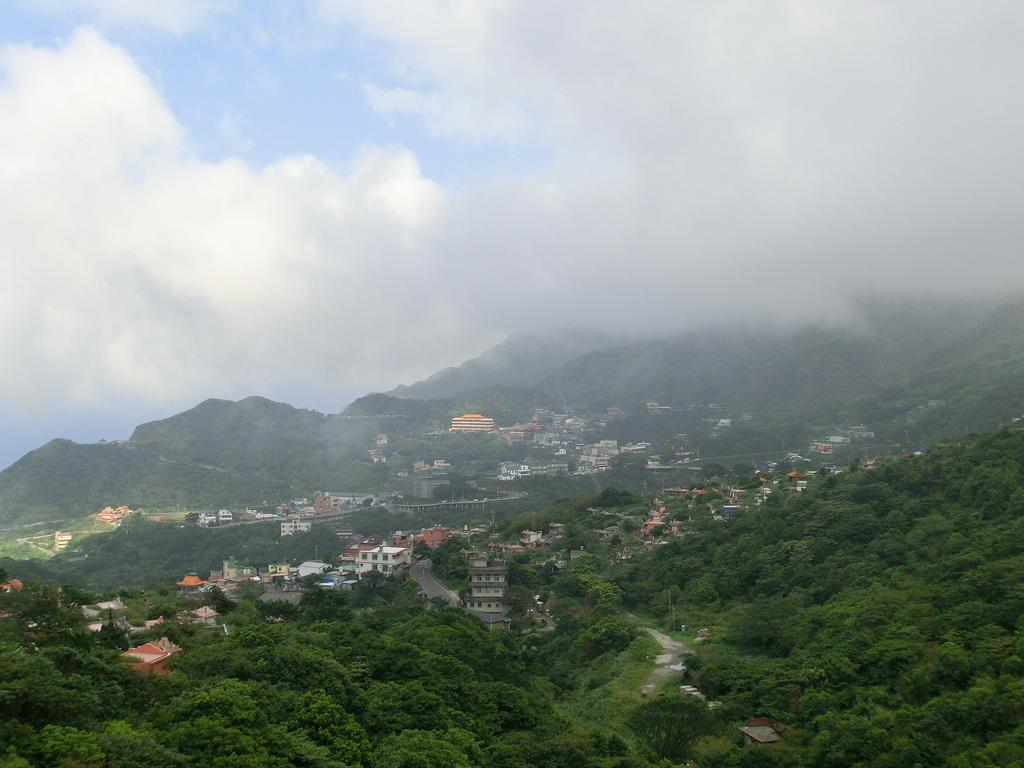What type of natural elements can be seen in the image? There are trees in the image. What type of man-made structures are present in the image? There are buildings in the image. What type of geographical feature can be seen in the image? There are mountains in the image. What is visible in the background of the image? The sky is visible in the image. How many cats are sitting on the roof of the building in the image? There are no cats present in the image; it features trees, buildings, mountains, and the sky. Can you tell me the color of the snail crawling on the mountain in the image? There is no snail present in the image; it features trees, buildings, mountains, and the sky. 